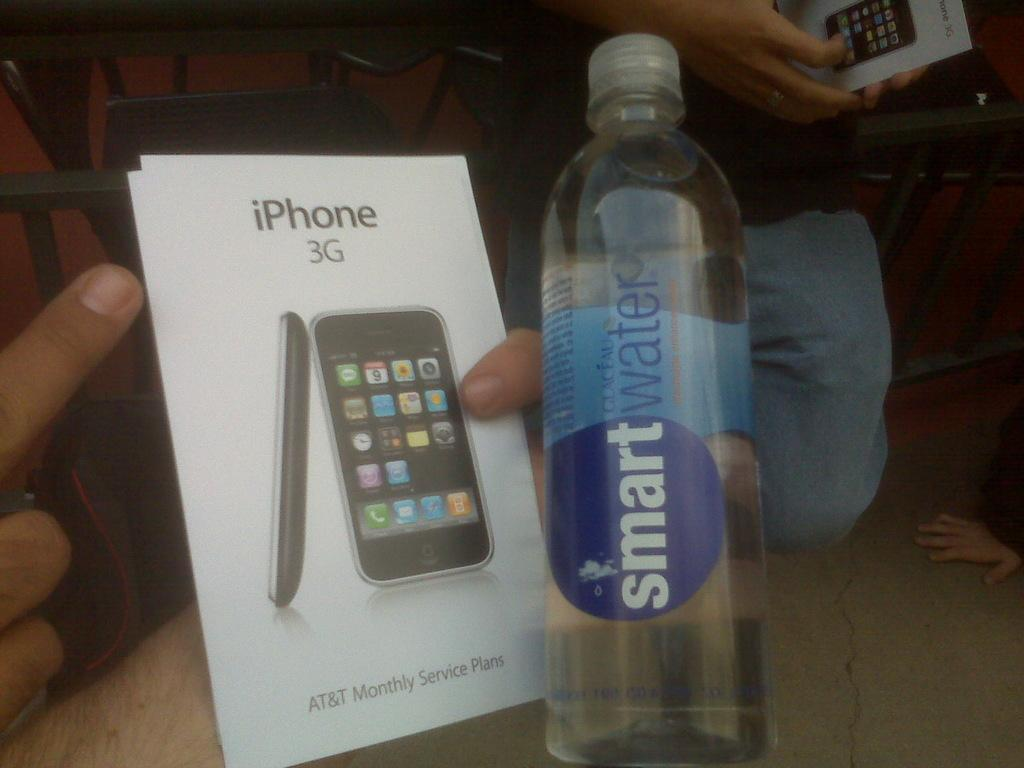<image>
Describe the image concisely. The box of an apple branded Iphone 3G with a bottle of smart water on the right. 